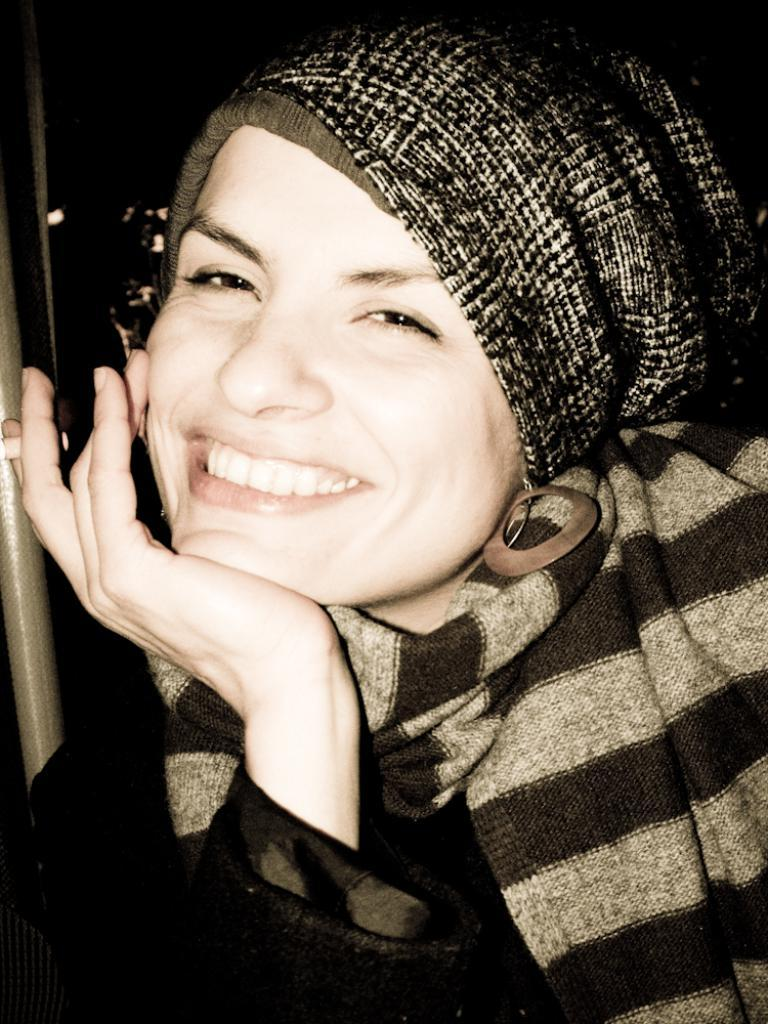Who is present in the image? There is a woman in the image. What is the woman doing with her hand? The woman has her hand to her chin. What is the woman's facial expression? The woman is smiling. What is on the woman's head? There is a cloth on the woman's head. What type of organization is the woman affiliated with in the image? There is no information about any organization in the image; it only features a woman with her hand to her chin, smiling, and wearing a cloth on her head. 